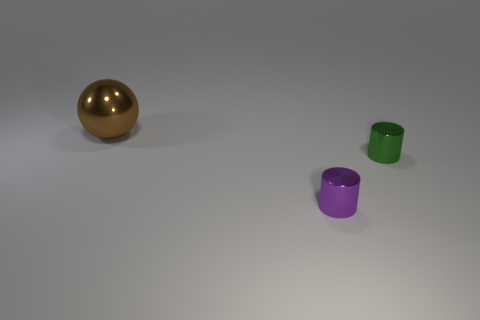If these objects were part of a game, what kind of game could it be? Considering their simple shapes and distinct colors, these objects could be part of a children's matching or sorting game, where the goal is to group items based on color or shape characteristics. 